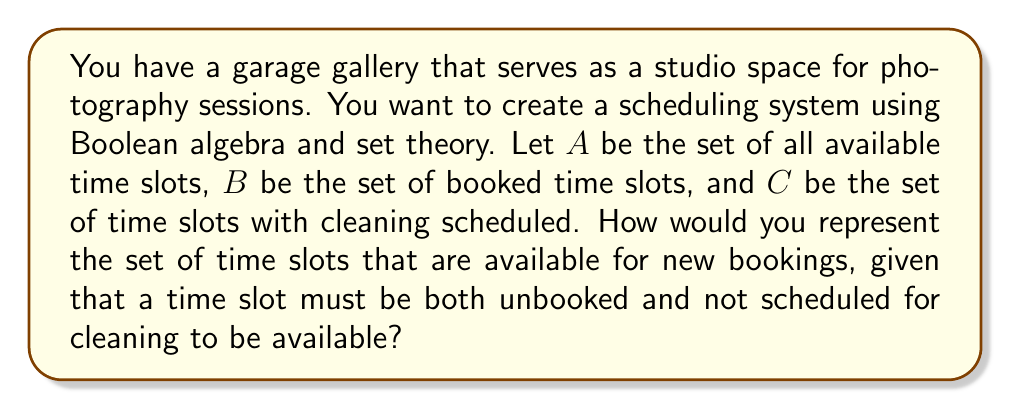Can you answer this question? To solve this problem, we'll use Boolean algebra and set theory concepts:

1. Define the universal set $U$ as all possible time slots in the garage gallery.

2. Given sets:
   $A$ = available time slots
   $B$ = booked time slots
   $C$ = time slots with cleaning scheduled

3. We need to find the set of time slots that are:
   - In set $A$ (available)
   - Not in set $B$ (not booked)
   - Not in set $C$ (not scheduled for cleaning)

4. In Boolean algebra, this can be represented as:
   $A \cap \overline{B} \cap \overline{C}$

   Where $\overline{B}$ and $\overline{C}$ represent the complements of sets $B$ and $C$ respectively.

5. Using De Morgan's laws, we can also express this as:
   $A \cap \overline{(B \cup C)}$

   This reads as: the intersection of available time slots and the complement of the union of booked and cleaning time slots.

6. In set theory notation, we can write this as:
   $A \setminus (B \cup C)$

   Which represents the set difference between $A$ and the union of $B$ and $C$.

Therefore, the set of time slots available for new bookings can be represented using any of these equivalent expressions:
$$A \cap \overline{B} \cap \overline{C}$$
$$A \cap \overline{(B \cup C)}$$
$$A \setminus (B \cup C)$$
Answer: $A \setminus (B \cup C)$ 